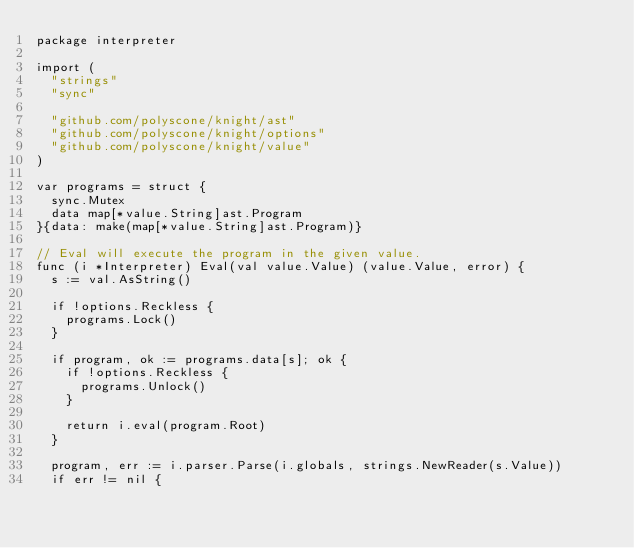<code> <loc_0><loc_0><loc_500><loc_500><_Go_>package interpreter

import (
	"strings"
	"sync"

	"github.com/polyscone/knight/ast"
	"github.com/polyscone/knight/options"
	"github.com/polyscone/knight/value"
)

var programs = struct {
	sync.Mutex
	data map[*value.String]ast.Program
}{data: make(map[*value.String]ast.Program)}

// Eval will execute the program in the given value.
func (i *Interpreter) Eval(val value.Value) (value.Value, error) {
	s := val.AsString()

	if !options.Reckless {
		programs.Lock()
	}

	if program, ok := programs.data[s]; ok {
		if !options.Reckless {
			programs.Unlock()
		}

		return i.eval(program.Root)
	}

	program, err := i.parser.Parse(i.globals, strings.NewReader(s.Value))
	if err != nil {</code> 